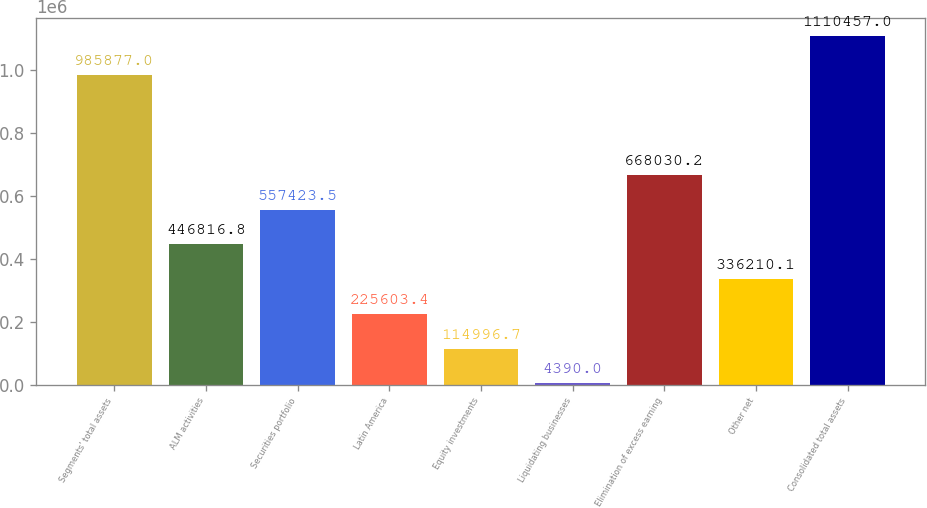<chart> <loc_0><loc_0><loc_500><loc_500><bar_chart><fcel>Segments' total assets<fcel>ALM activities<fcel>Securities portfolio<fcel>Latin America<fcel>Equity investments<fcel>Liquidating businesses<fcel>Elimination of excess earning<fcel>Other net<fcel>Consolidated total assets<nl><fcel>985877<fcel>446817<fcel>557424<fcel>225603<fcel>114997<fcel>4390<fcel>668030<fcel>336210<fcel>1.11046e+06<nl></chart> 